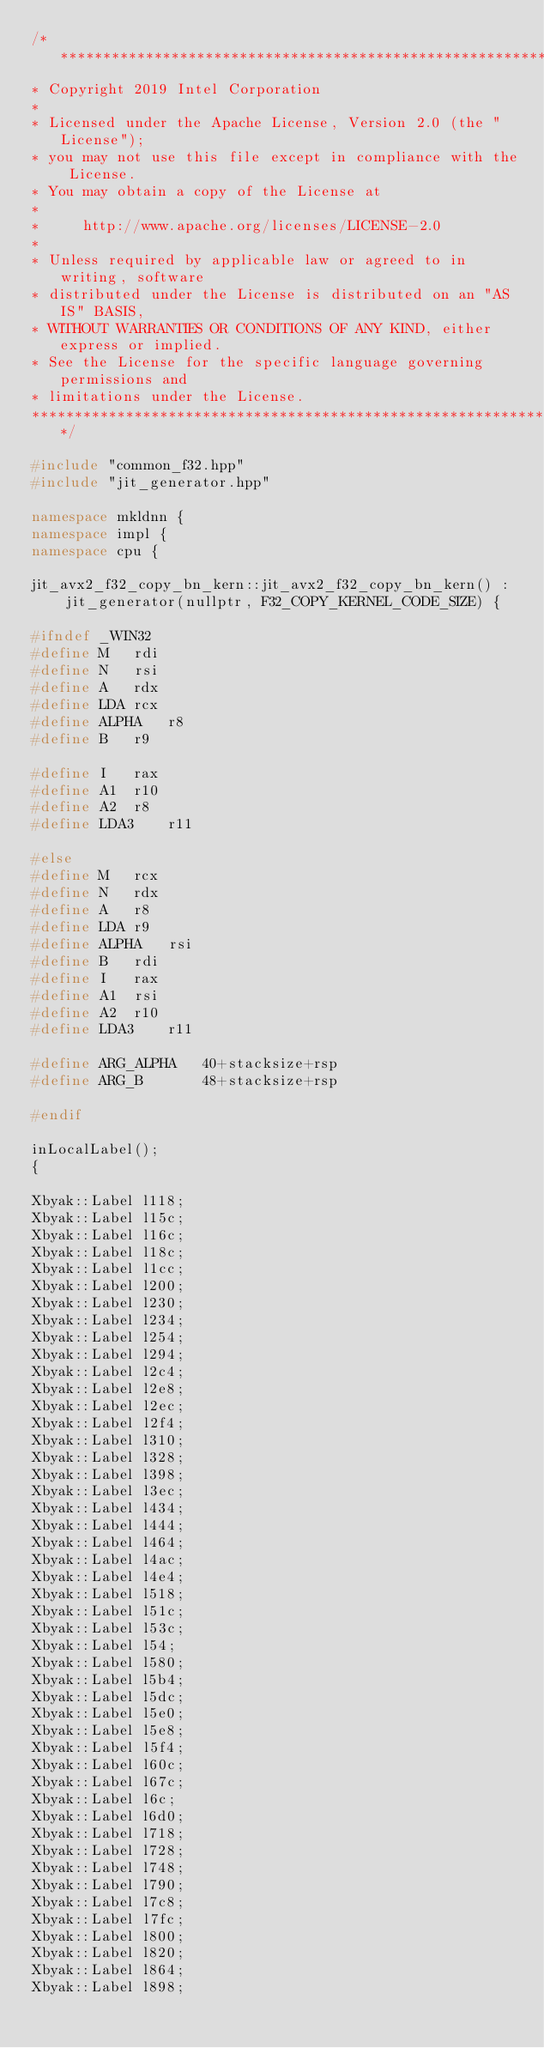<code> <loc_0><loc_0><loc_500><loc_500><_C++_>/*******************************************************************************
* Copyright 2019 Intel Corporation
*
* Licensed under the Apache License, Version 2.0 (the "License");
* you may not use this file except in compliance with the License.
* You may obtain a copy of the License at
*
*     http://www.apache.org/licenses/LICENSE-2.0
*
* Unless required by applicable law or agreed to in writing, software
* distributed under the License is distributed on an "AS IS" BASIS,
* WITHOUT WARRANTIES OR CONDITIONS OF ANY KIND, either express or implied.
* See the License for the specific language governing permissions and
* limitations under the License.
*******************************************************************************/

#include "common_f32.hpp"
#include "jit_generator.hpp"

namespace mkldnn {
namespace impl {
namespace cpu {

jit_avx2_f32_copy_bn_kern::jit_avx2_f32_copy_bn_kern() :
    jit_generator(nullptr, F32_COPY_KERNEL_CODE_SIZE) {

#ifndef _WIN32
#define M   rdi
#define N   rsi
#define A   rdx
#define LDA rcx
#define ALPHA   r8
#define B   r9

#define I   rax
#define A1  r10
#define A2  r8
#define LDA3    r11

#else
#define M   rcx
#define N   rdx
#define A   r8
#define LDA r9
#define ALPHA   rsi
#define B   rdi
#define I   rax
#define A1  rsi
#define A2  r10
#define LDA3    r11

#define ARG_ALPHA   40+stacksize+rsp
#define ARG_B       48+stacksize+rsp

#endif

inLocalLabel();
{

Xbyak::Label l118;
Xbyak::Label l15c;
Xbyak::Label l16c;
Xbyak::Label l18c;
Xbyak::Label l1cc;
Xbyak::Label l200;
Xbyak::Label l230;
Xbyak::Label l234;
Xbyak::Label l254;
Xbyak::Label l294;
Xbyak::Label l2c4;
Xbyak::Label l2e8;
Xbyak::Label l2ec;
Xbyak::Label l2f4;
Xbyak::Label l310;
Xbyak::Label l328;
Xbyak::Label l398;
Xbyak::Label l3ec;
Xbyak::Label l434;
Xbyak::Label l444;
Xbyak::Label l464;
Xbyak::Label l4ac;
Xbyak::Label l4e4;
Xbyak::Label l518;
Xbyak::Label l51c;
Xbyak::Label l53c;
Xbyak::Label l54;
Xbyak::Label l580;
Xbyak::Label l5b4;
Xbyak::Label l5dc;
Xbyak::Label l5e0;
Xbyak::Label l5e8;
Xbyak::Label l5f4;
Xbyak::Label l60c;
Xbyak::Label l67c;
Xbyak::Label l6c;
Xbyak::Label l6d0;
Xbyak::Label l718;
Xbyak::Label l728;
Xbyak::Label l748;
Xbyak::Label l790;
Xbyak::Label l7c8;
Xbyak::Label l7fc;
Xbyak::Label l800;
Xbyak::Label l820;
Xbyak::Label l864;
Xbyak::Label l898;</code> 